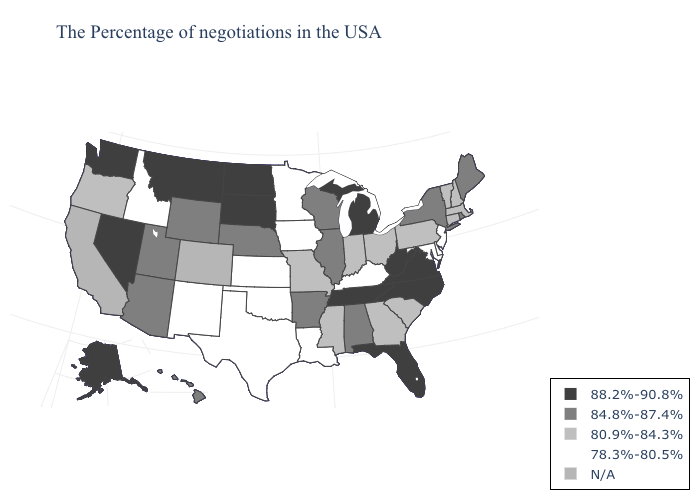What is the value of Indiana?
Give a very brief answer. 80.9%-84.3%. What is the lowest value in the USA?
Write a very short answer. 78.3%-80.5%. Name the states that have a value in the range 88.2%-90.8%?
Answer briefly. Virginia, North Carolina, West Virginia, Florida, Michigan, Tennessee, South Dakota, North Dakota, Montana, Nevada, Washington, Alaska. What is the highest value in states that border Iowa?
Give a very brief answer. 88.2%-90.8%. What is the lowest value in the South?
Short answer required. 78.3%-80.5%. Which states have the lowest value in the USA?
Be succinct. New Jersey, Delaware, Maryland, Kentucky, Louisiana, Minnesota, Iowa, Kansas, Oklahoma, Texas, New Mexico, Idaho. Does the first symbol in the legend represent the smallest category?
Quick response, please. No. Does Indiana have the lowest value in the USA?
Be succinct. No. Which states have the highest value in the USA?
Concise answer only. Virginia, North Carolina, West Virginia, Florida, Michigan, Tennessee, South Dakota, North Dakota, Montana, Nevada, Washington, Alaska. Does Florida have the lowest value in the USA?
Short answer required. No. What is the highest value in states that border New Hampshire?
Concise answer only. 84.8%-87.4%. Among the states that border Illinois , does Kentucky have the lowest value?
Quick response, please. Yes. How many symbols are there in the legend?
Keep it brief. 5. Does the first symbol in the legend represent the smallest category?
Give a very brief answer. No. Does Minnesota have the highest value in the USA?
Answer briefly. No. 